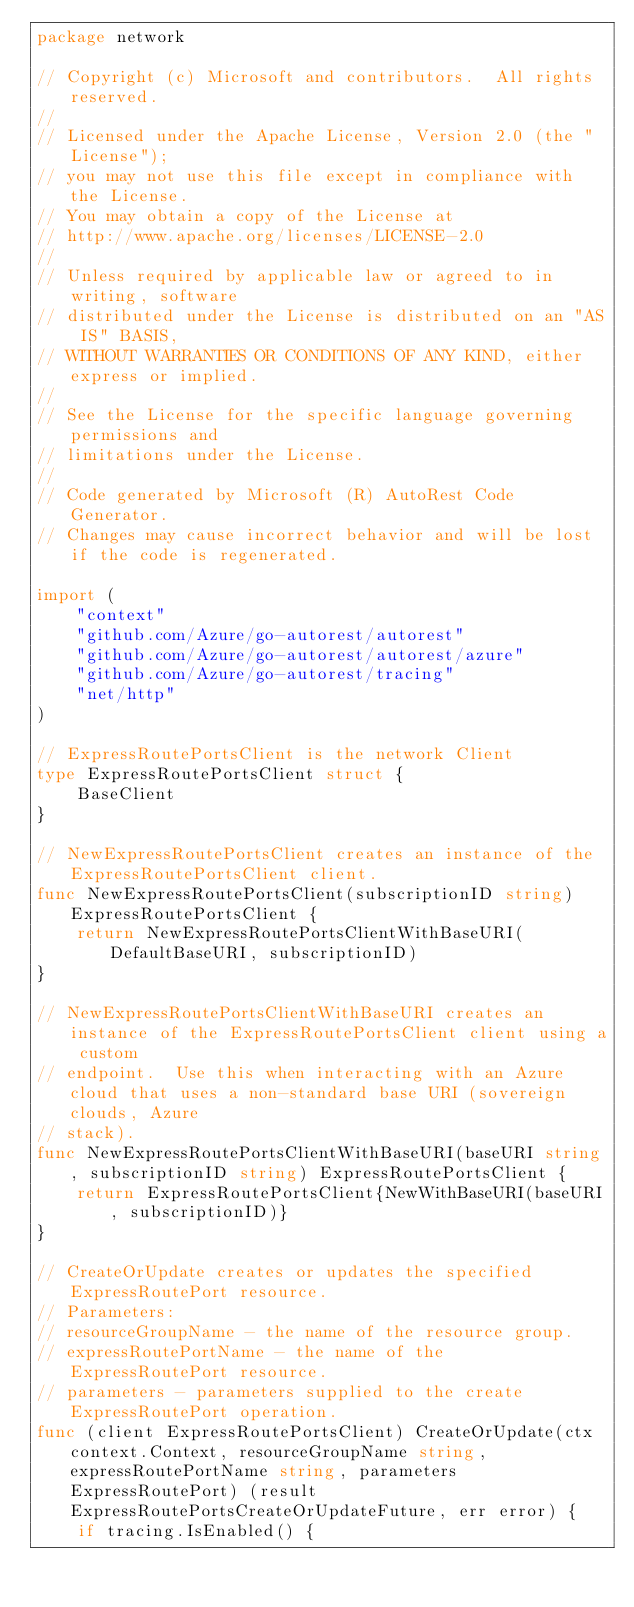Convert code to text. <code><loc_0><loc_0><loc_500><loc_500><_Go_>package network

// Copyright (c) Microsoft and contributors.  All rights reserved.
//
// Licensed under the Apache License, Version 2.0 (the "License");
// you may not use this file except in compliance with the License.
// You may obtain a copy of the License at
// http://www.apache.org/licenses/LICENSE-2.0
//
// Unless required by applicable law or agreed to in writing, software
// distributed under the License is distributed on an "AS IS" BASIS,
// WITHOUT WARRANTIES OR CONDITIONS OF ANY KIND, either express or implied.
//
// See the License for the specific language governing permissions and
// limitations under the License.
//
// Code generated by Microsoft (R) AutoRest Code Generator.
// Changes may cause incorrect behavior and will be lost if the code is regenerated.

import (
	"context"
	"github.com/Azure/go-autorest/autorest"
	"github.com/Azure/go-autorest/autorest/azure"
	"github.com/Azure/go-autorest/tracing"
	"net/http"
)

// ExpressRoutePortsClient is the network Client
type ExpressRoutePortsClient struct {
	BaseClient
}

// NewExpressRoutePortsClient creates an instance of the ExpressRoutePortsClient client.
func NewExpressRoutePortsClient(subscriptionID string) ExpressRoutePortsClient {
	return NewExpressRoutePortsClientWithBaseURI(DefaultBaseURI, subscriptionID)
}

// NewExpressRoutePortsClientWithBaseURI creates an instance of the ExpressRoutePortsClient client using a custom
// endpoint.  Use this when interacting with an Azure cloud that uses a non-standard base URI (sovereign clouds, Azure
// stack).
func NewExpressRoutePortsClientWithBaseURI(baseURI string, subscriptionID string) ExpressRoutePortsClient {
	return ExpressRoutePortsClient{NewWithBaseURI(baseURI, subscriptionID)}
}

// CreateOrUpdate creates or updates the specified ExpressRoutePort resource.
// Parameters:
// resourceGroupName - the name of the resource group.
// expressRoutePortName - the name of the ExpressRoutePort resource.
// parameters - parameters supplied to the create ExpressRoutePort operation.
func (client ExpressRoutePortsClient) CreateOrUpdate(ctx context.Context, resourceGroupName string, expressRoutePortName string, parameters ExpressRoutePort) (result ExpressRoutePortsCreateOrUpdateFuture, err error) {
	if tracing.IsEnabled() {</code> 